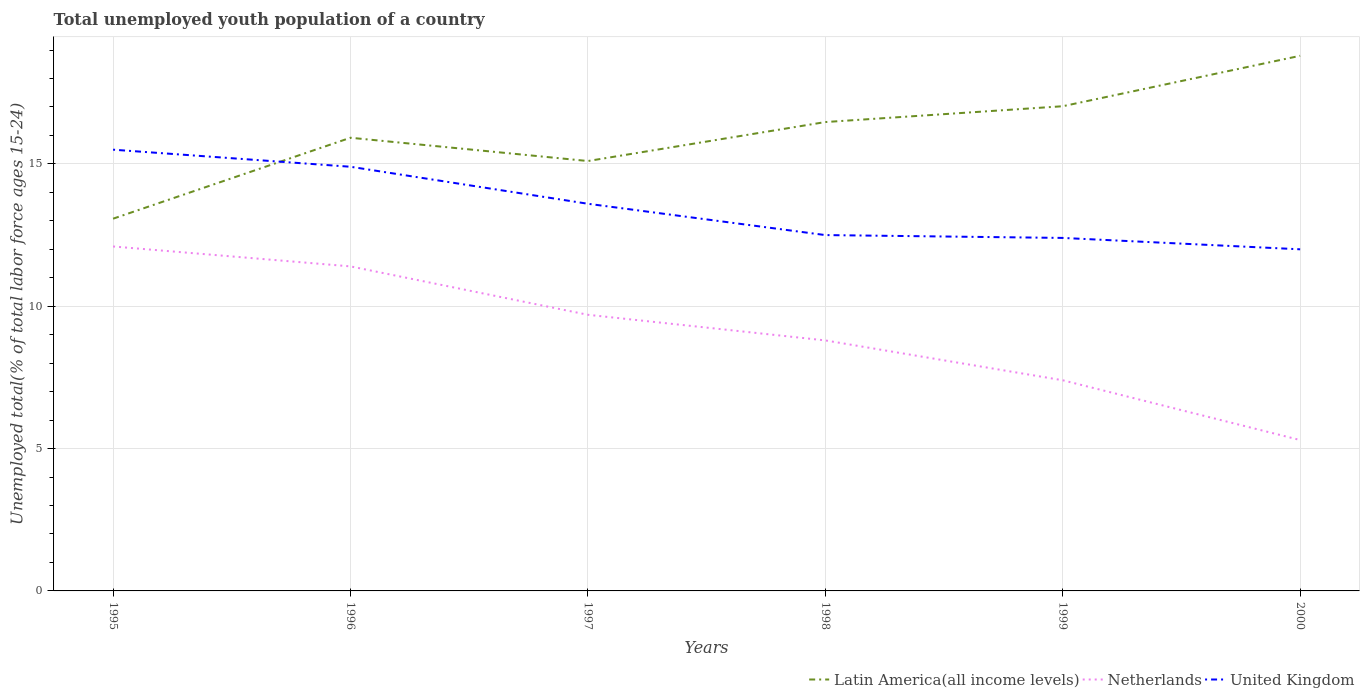How many different coloured lines are there?
Offer a very short reply. 3. Is the number of lines equal to the number of legend labels?
Your response must be concise. Yes. In which year was the percentage of total unemployed youth population of a country in Netherlands maximum?
Your answer should be very brief. 2000. What is the total percentage of total unemployed youth population of a country in Latin America(all income levels) in the graph?
Make the answer very short. -2.03. What is the difference between the highest and the second highest percentage of total unemployed youth population of a country in Latin America(all income levels)?
Provide a succinct answer. 5.72. What is the difference between the highest and the lowest percentage of total unemployed youth population of a country in Netherlands?
Your answer should be compact. 3. Is the percentage of total unemployed youth population of a country in United Kingdom strictly greater than the percentage of total unemployed youth population of a country in Latin America(all income levels) over the years?
Provide a short and direct response. No. How many lines are there?
Give a very brief answer. 3. What is the title of the graph?
Offer a very short reply. Total unemployed youth population of a country. What is the label or title of the X-axis?
Offer a very short reply. Years. What is the label or title of the Y-axis?
Offer a very short reply. Unemployed total(% of total labor force ages 15-24). What is the Unemployed total(% of total labor force ages 15-24) in Latin America(all income levels) in 1995?
Offer a very short reply. 13.08. What is the Unemployed total(% of total labor force ages 15-24) in Netherlands in 1995?
Offer a very short reply. 12.1. What is the Unemployed total(% of total labor force ages 15-24) of Latin America(all income levels) in 1996?
Keep it short and to the point. 15.92. What is the Unemployed total(% of total labor force ages 15-24) of Netherlands in 1996?
Offer a very short reply. 11.4. What is the Unemployed total(% of total labor force ages 15-24) of United Kingdom in 1996?
Ensure brevity in your answer.  14.9. What is the Unemployed total(% of total labor force ages 15-24) of Latin America(all income levels) in 1997?
Your answer should be compact. 15.1. What is the Unemployed total(% of total labor force ages 15-24) of Netherlands in 1997?
Keep it short and to the point. 9.7. What is the Unemployed total(% of total labor force ages 15-24) of United Kingdom in 1997?
Give a very brief answer. 13.6. What is the Unemployed total(% of total labor force ages 15-24) in Latin America(all income levels) in 1998?
Your answer should be compact. 16.47. What is the Unemployed total(% of total labor force ages 15-24) of Netherlands in 1998?
Offer a terse response. 8.8. What is the Unemployed total(% of total labor force ages 15-24) in United Kingdom in 1998?
Your answer should be compact. 12.5. What is the Unemployed total(% of total labor force ages 15-24) of Latin America(all income levels) in 1999?
Provide a succinct answer. 17.03. What is the Unemployed total(% of total labor force ages 15-24) of Netherlands in 1999?
Provide a succinct answer. 7.4. What is the Unemployed total(% of total labor force ages 15-24) of United Kingdom in 1999?
Keep it short and to the point. 12.4. What is the Unemployed total(% of total labor force ages 15-24) in Latin America(all income levels) in 2000?
Your answer should be compact. 18.8. What is the Unemployed total(% of total labor force ages 15-24) in Netherlands in 2000?
Make the answer very short. 5.3. What is the Unemployed total(% of total labor force ages 15-24) of United Kingdom in 2000?
Your response must be concise. 12. Across all years, what is the maximum Unemployed total(% of total labor force ages 15-24) in Latin America(all income levels)?
Make the answer very short. 18.8. Across all years, what is the maximum Unemployed total(% of total labor force ages 15-24) of Netherlands?
Make the answer very short. 12.1. Across all years, what is the maximum Unemployed total(% of total labor force ages 15-24) of United Kingdom?
Provide a succinct answer. 15.5. Across all years, what is the minimum Unemployed total(% of total labor force ages 15-24) of Latin America(all income levels)?
Make the answer very short. 13.08. Across all years, what is the minimum Unemployed total(% of total labor force ages 15-24) in Netherlands?
Provide a short and direct response. 5.3. What is the total Unemployed total(% of total labor force ages 15-24) in Latin America(all income levels) in the graph?
Keep it short and to the point. 96.39. What is the total Unemployed total(% of total labor force ages 15-24) in Netherlands in the graph?
Make the answer very short. 54.7. What is the total Unemployed total(% of total labor force ages 15-24) in United Kingdom in the graph?
Provide a short and direct response. 80.9. What is the difference between the Unemployed total(% of total labor force ages 15-24) in Latin America(all income levels) in 1995 and that in 1996?
Offer a very short reply. -2.84. What is the difference between the Unemployed total(% of total labor force ages 15-24) in Latin America(all income levels) in 1995 and that in 1997?
Offer a very short reply. -2.03. What is the difference between the Unemployed total(% of total labor force ages 15-24) in Netherlands in 1995 and that in 1997?
Provide a short and direct response. 2.4. What is the difference between the Unemployed total(% of total labor force ages 15-24) of Latin America(all income levels) in 1995 and that in 1998?
Provide a short and direct response. -3.39. What is the difference between the Unemployed total(% of total labor force ages 15-24) in Netherlands in 1995 and that in 1998?
Your response must be concise. 3.3. What is the difference between the Unemployed total(% of total labor force ages 15-24) of Latin America(all income levels) in 1995 and that in 1999?
Offer a terse response. -3.95. What is the difference between the Unemployed total(% of total labor force ages 15-24) in Netherlands in 1995 and that in 1999?
Ensure brevity in your answer.  4.7. What is the difference between the Unemployed total(% of total labor force ages 15-24) in United Kingdom in 1995 and that in 1999?
Keep it short and to the point. 3.1. What is the difference between the Unemployed total(% of total labor force ages 15-24) of Latin America(all income levels) in 1995 and that in 2000?
Your answer should be very brief. -5.72. What is the difference between the Unemployed total(% of total labor force ages 15-24) of Netherlands in 1995 and that in 2000?
Provide a short and direct response. 6.8. What is the difference between the Unemployed total(% of total labor force ages 15-24) in United Kingdom in 1995 and that in 2000?
Keep it short and to the point. 3.5. What is the difference between the Unemployed total(% of total labor force ages 15-24) in Latin America(all income levels) in 1996 and that in 1997?
Your answer should be very brief. 0.82. What is the difference between the Unemployed total(% of total labor force ages 15-24) of Latin America(all income levels) in 1996 and that in 1998?
Give a very brief answer. -0.55. What is the difference between the Unemployed total(% of total labor force ages 15-24) of United Kingdom in 1996 and that in 1998?
Your answer should be compact. 2.4. What is the difference between the Unemployed total(% of total labor force ages 15-24) of Latin America(all income levels) in 1996 and that in 1999?
Make the answer very short. -1.11. What is the difference between the Unemployed total(% of total labor force ages 15-24) of Netherlands in 1996 and that in 1999?
Your answer should be very brief. 4. What is the difference between the Unemployed total(% of total labor force ages 15-24) of Latin America(all income levels) in 1996 and that in 2000?
Offer a very short reply. -2.88. What is the difference between the Unemployed total(% of total labor force ages 15-24) of United Kingdom in 1996 and that in 2000?
Provide a succinct answer. 2.9. What is the difference between the Unemployed total(% of total labor force ages 15-24) in Latin America(all income levels) in 1997 and that in 1998?
Keep it short and to the point. -1.37. What is the difference between the Unemployed total(% of total labor force ages 15-24) in Netherlands in 1997 and that in 1998?
Your answer should be very brief. 0.9. What is the difference between the Unemployed total(% of total labor force ages 15-24) in Latin America(all income levels) in 1997 and that in 1999?
Give a very brief answer. -1.92. What is the difference between the Unemployed total(% of total labor force ages 15-24) of Netherlands in 1997 and that in 1999?
Your answer should be very brief. 2.3. What is the difference between the Unemployed total(% of total labor force ages 15-24) in Latin America(all income levels) in 1997 and that in 2000?
Keep it short and to the point. -3.7. What is the difference between the Unemployed total(% of total labor force ages 15-24) of Netherlands in 1997 and that in 2000?
Make the answer very short. 4.4. What is the difference between the Unemployed total(% of total labor force ages 15-24) in United Kingdom in 1997 and that in 2000?
Give a very brief answer. 1.6. What is the difference between the Unemployed total(% of total labor force ages 15-24) of Latin America(all income levels) in 1998 and that in 1999?
Give a very brief answer. -0.56. What is the difference between the Unemployed total(% of total labor force ages 15-24) of Netherlands in 1998 and that in 1999?
Your answer should be compact. 1.4. What is the difference between the Unemployed total(% of total labor force ages 15-24) in United Kingdom in 1998 and that in 1999?
Offer a terse response. 0.1. What is the difference between the Unemployed total(% of total labor force ages 15-24) in Latin America(all income levels) in 1998 and that in 2000?
Your answer should be compact. -2.33. What is the difference between the Unemployed total(% of total labor force ages 15-24) in Latin America(all income levels) in 1999 and that in 2000?
Offer a terse response. -1.77. What is the difference between the Unemployed total(% of total labor force ages 15-24) of Latin America(all income levels) in 1995 and the Unemployed total(% of total labor force ages 15-24) of Netherlands in 1996?
Offer a terse response. 1.68. What is the difference between the Unemployed total(% of total labor force ages 15-24) in Latin America(all income levels) in 1995 and the Unemployed total(% of total labor force ages 15-24) in United Kingdom in 1996?
Ensure brevity in your answer.  -1.82. What is the difference between the Unemployed total(% of total labor force ages 15-24) in Netherlands in 1995 and the Unemployed total(% of total labor force ages 15-24) in United Kingdom in 1996?
Provide a short and direct response. -2.8. What is the difference between the Unemployed total(% of total labor force ages 15-24) in Latin America(all income levels) in 1995 and the Unemployed total(% of total labor force ages 15-24) in Netherlands in 1997?
Make the answer very short. 3.38. What is the difference between the Unemployed total(% of total labor force ages 15-24) of Latin America(all income levels) in 1995 and the Unemployed total(% of total labor force ages 15-24) of United Kingdom in 1997?
Your answer should be compact. -0.52. What is the difference between the Unemployed total(% of total labor force ages 15-24) in Latin America(all income levels) in 1995 and the Unemployed total(% of total labor force ages 15-24) in Netherlands in 1998?
Provide a succinct answer. 4.28. What is the difference between the Unemployed total(% of total labor force ages 15-24) of Latin America(all income levels) in 1995 and the Unemployed total(% of total labor force ages 15-24) of United Kingdom in 1998?
Provide a short and direct response. 0.58. What is the difference between the Unemployed total(% of total labor force ages 15-24) of Netherlands in 1995 and the Unemployed total(% of total labor force ages 15-24) of United Kingdom in 1998?
Offer a terse response. -0.4. What is the difference between the Unemployed total(% of total labor force ages 15-24) in Latin America(all income levels) in 1995 and the Unemployed total(% of total labor force ages 15-24) in Netherlands in 1999?
Offer a terse response. 5.68. What is the difference between the Unemployed total(% of total labor force ages 15-24) of Latin America(all income levels) in 1995 and the Unemployed total(% of total labor force ages 15-24) of United Kingdom in 1999?
Offer a terse response. 0.68. What is the difference between the Unemployed total(% of total labor force ages 15-24) of Netherlands in 1995 and the Unemployed total(% of total labor force ages 15-24) of United Kingdom in 1999?
Your answer should be very brief. -0.3. What is the difference between the Unemployed total(% of total labor force ages 15-24) of Latin America(all income levels) in 1995 and the Unemployed total(% of total labor force ages 15-24) of Netherlands in 2000?
Keep it short and to the point. 7.78. What is the difference between the Unemployed total(% of total labor force ages 15-24) in Latin America(all income levels) in 1995 and the Unemployed total(% of total labor force ages 15-24) in United Kingdom in 2000?
Provide a succinct answer. 1.08. What is the difference between the Unemployed total(% of total labor force ages 15-24) in Latin America(all income levels) in 1996 and the Unemployed total(% of total labor force ages 15-24) in Netherlands in 1997?
Make the answer very short. 6.22. What is the difference between the Unemployed total(% of total labor force ages 15-24) in Latin America(all income levels) in 1996 and the Unemployed total(% of total labor force ages 15-24) in United Kingdom in 1997?
Ensure brevity in your answer.  2.32. What is the difference between the Unemployed total(% of total labor force ages 15-24) in Latin America(all income levels) in 1996 and the Unemployed total(% of total labor force ages 15-24) in Netherlands in 1998?
Give a very brief answer. 7.12. What is the difference between the Unemployed total(% of total labor force ages 15-24) of Latin America(all income levels) in 1996 and the Unemployed total(% of total labor force ages 15-24) of United Kingdom in 1998?
Offer a terse response. 3.42. What is the difference between the Unemployed total(% of total labor force ages 15-24) of Netherlands in 1996 and the Unemployed total(% of total labor force ages 15-24) of United Kingdom in 1998?
Keep it short and to the point. -1.1. What is the difference between the Unemployed total(% of total labor force ages 15-24) of Latin America(all income levels) in 1996 and the Unemployed total(% of total labor force ages 15-24) of Netherlands in 1999?
Your response must be concise. 8.52. What is the difference between the Unemployed total(% of total labor force ages 15-24) of Latin America(all income levels) in 1996 and the Unemployed total(% of total labor force ages 15-24) of United Kingdom in 1999?
Your answer should be compact. 3.52. What is the difference between the Unemployed total(% of total labor force ages 15-24) in Netherlands in 1996 and the Unemployed total(% of total labor force ages 15-24) in United Kingdom in 1999?
Provide a succinct answer. -1. What is the difference between the Unemployed total(% of total labor force ages 15-24) of Latin America(all income levels) in 1996 and the Unemployed total(% of total labor force ages 15-24) of Netherlands in 2000?
Provide a short and direct response. 10.62. What is the difference between the Unemployed total(% of total labor force ages 15-24) of Latin America(all income levels) in 1996 and the Unemployed total(% of total labor force ages 15-24) of United Kingdom in 2000?
Provide a short and direct response. 3.92. What is the difference between the Unemployed total(% of total labor force ages 15-24) of Latin America(all income levels) in 1997 and the Unemployed total(% of total labor force ages 15-24) of Netherlands in 1998?
Make the answer very short. 6.3. What is the difference between the Unemployed total(% of total labor force ages 15-24) of Latin America(all income levels) in 1997 and the Unemployed total(% of total labor force ages 15-24) of United Kingdom in 1998?
Provide a short and direct response. 2.6. What is the difference between the Unemployed total(% of total labor force ages 15-24) in Netherlands in 1997 and the Unemployed total(% of total labor force ages 15-24) in United Kingdom in 1998?
Provide a succinct answer. -2.8. What is the difference between the Unemployed total(% of total labor force ages 15-24) in Latin America(all income levels) in 1997 and the Unemployed total(% of total labor force ages 15-24) in Netherlands in 1999?
Give a very brief answer. 7.7. What is the difference between the Unemployed total(% of total labor force ages 15-24) in Latin America(all income levels) in 1997 and the Unemployed total(% of total labor force ages 15-24) in United Kingdom in 1999?
Give a very brief answer. 2.7. What is the difference between the Unemployed total(% of total labor force ages 15-24) of Latin America(all income levels) in 1997 and the Unemployed total(% of total labor force ages 15-24) of Netherlands in 2000?
Your answer should be very brief. 9.8. What is the difference between the Unemployed total(% of total labor force ages 15-24) of Latin America(all income levels) in 1997 and the Unemployed total(% of total labor force ages 15-24) of United Kingdom in 2000?
Provide a succinct answer. 3.1. What is the difference between the Unemployed total(% of total labor force ages 15-24) in Latin America(all income levels) in 1998 and the Unemployed total(% of total labor force ages 15-24) in Netherlands in 1999?
Offer a very short reply. 9.07. What is the difference between the Unemployed total(% of total labor force ages 15-24) of Latin America(all income levels) in 1998 and the Unemployed total(% of total labor force ages 15-24) of United Kingdom in 1999?
Your answer should be compact. 4.07. What is the difference between the Unemployed total(% of total labor force ages 15-24) in Netherlands in 1998 and the Unemployed total(% of total labor force ages 15-24) in United Kingdom in 1999?
Provide a succinct answer. -3.6. What is the difference between the Unemployed total(% of total labor force ages 15-24) of Latin America(all income levels) in 1998 and the Unemployed total(% of total labor force ages 15-24) of Netherlands in 2000?
Make the answer very short. 11.17. What is the difference between the Unemployed total(% of total labor force ages 15-24) of Latin America(all income levels) in 1998 and the Unemployed total(% of total labor force ages 15-24) of United Kingdom in 2000?
Your answer should be very brief. 4.47. What is the difference between the Unemployed total(% of total labor force ages 15-24) in Latin America(all income levels) in 1999 and the Unemployed total(% of total labor force ages 15-24) in Netherlands in 2000?
Provide a short and direct response. 11.73. What is the difference between the Unemployed total(% of total labor force ages 15-24) of Latin America(all income levels) in 1999 and the Unemployed total(% of total labor force ages 15-24) of United Kingdom in 2000?
Ensure brevity in your answer.  5.03. What is the difference between the Unemployed total(% of total labor force ages 15-24) in Netherlands in 1999 and the Unemployed total(% of total labor force ages 15-24) in United Kingdom in 2000?
Ensure brevity in your answer.  -4.6. What is the average Unemployed total(% of total labor force ages 15-24) of Latin America(all income levels) per year?
Your answer should be compact. 16.07. What is the average Unemployed total(% of total labor force ages 15-24) of Netherlands per year?
Offer a very short reply. 9.12. What is the average Unemployed total(% of total labor force ages 15-24) of United Kingdom per year?
Offer a terse response. 13.48. In the year 1995, what is the difference between the Unemployed total(% of total labor force ages 15-24) of Latin America(all income levels) and Unemployed total(% of total labor force ages 15-24) of Netherlands?
Keep it short and to the point. 0.98. In the year 1995, what is the difference between the Unemployed total(% of total labor force ages 15-24) of Latin America(all income levels) and Unemployed total(% of total labor force ages 15-24) of United Kingdom?
Offer a very short reply. -2.42. In the year 1995, what is the difference between the Unemployed total(% of total labor force ages 15-24) in Netherlands and Unemployed total(% of total labor force ages 15-24) in United Kingdom?
Your answer should be compact. -3.4. In the year 1996, what is the difference between the Unemployed total(% of total labor force ages 15-24) in Latin America(all income levels) and Unemployed total(% of total labor force ages 15-24) in Netherlands?
Your response must be concise. 4.52. In the year 1996, what is the difference between the Unemployed total(% of total labor force ages 15-24) of Latin America(all income levels) and Unemployed total(% of total labor force ages 15-24) of United Kingdom?
Your answer should be compact. 1.02. In the year 1997, what is the difference between the Unemployed total(% of total labor force ages 15-24) of Latin America(all income levels) and Unemployed total(% of total labor force ages 15-24) of Netherlands?
Provide a succinct answer. 5.4. In the year 1997, what is the difference between the Unemployed total(% of total labor force ages 15-24) in Latin America(all income levels) and Unemployed total(% of total labor force ages 15-24) in United Kingdom?
Provide a succinct answer. 1.5. In the year 1997, what is the difference between the Unemployed total(% of total labor force ages 15-24) in Netherlands and Unemployed total(% of total labor force ages 15-24) in United Kingdom?
Your answer should be very brief. -3.9. In the year 1998, what is the difference between the Unemployed total(% of total labor force ages 15-24) in Latin America(all income levels) and Unemployed total(% of total labor force ages 15-24) in Netherlands?
Offer a terse response. 7.67. In the year 1998, what is the difference between the Unemployed total(% of total labor force ages 15-24) in Latin America(all income levels) and Unemployed total(% of total labor force ages 15-24) in United Kingdom?
Ensure brevity in your answer.  3.97. In the year 1998, what is the difference between the Unemployed total(% of total labor force ages 15-24) in Netherlands and Unemployed total(% of total labor force ages 15-24) in United Kingdom?
Make the answer very short. -3.7. In the year 1999, what is the difference between the Unemployed total(% of total labor force ages 15-24) in Latin America(all income levels) and Unemployed total(% of total labor force ages 15-24) in Netherlands?
Make the answer very short. 9.63. In the year 1999, what is the difference between the Unemployed total(% of total labor force ages 15-24) in Latin America(all income levels) and Unemployed total(% of total labor force ages 15-24) in United Kingdom?
Offer a very short reply. 4.63. In the year 2000, what is the difference between the Unemployed total(% of total labor force ages 15-24) of Latin America(all income levels) and Unemployed total(% of total labor force ages 15-24) of Netherlands?
Keep it short and to the point. 13.5. In the year 2000, what is the difference between the Unemployed total(% of total labor force ages 15-24) in Latin America(all income levels) and Unemployed total(% of total labor force ages 15-24) in United Kingdom?
Make the answer very short. 6.8. What is the ratio of the Unemployed total(% of total labor force ages 15-24) of Latin America(all income levels) in 1995 to that in 1996?
Offer a very short reply. 0.82. What is the ratio of the Unemployed total(% of total labor force ages 15-24) in Netherlands in 1995 to that in 1996?
Offer a terse response. 1.06. What is the ratio of the Unemployed total(% of total labor force ages 15-24) of United Kingdom in 1995 to that in 1996?
Make the answer very short. 1.04. What is the ratio of the Unemployed total(% of total labor force ages 15-24) in Latin America(all income levels) in 1995 to that in 1997?
Offer a very short reply. 0.87. What is the ratio of the Unemployed total(% of total labor force ages 15-24) in Netherlands in 1995 to that in 1997?
Your response must be concise. 1.25. What is the ratio of the Unemployed total(% of total labor force ages 15-24) of United Kingdom in 1995 to that in 1997?
Your answer should be compact. 1.14. What is the ratio of the Unemployed total(% of total labor force ages 15-24) of Latin America(all income levels) in 1995 to that in 1998?
Make the answer very short. 0.79. What is the ratio of the Unemployed total(% of total labor force ages 15-24) of Netherlands in 1995 to that in 1998?
Your answer should be compact. 1.38. What is the ratio of the Unemployed total(% of total labor force ages 15-24) of United Kingdom in 1995 to that in 1998?
Your answer should be very brief. 1.24. What is the ratio of the Unemployed total(% of total labor force ages 15-24) of Latin America(all income levels) in 1995 to that in 1999?
Your response must be concise. 0.77. What is the ratio of the Unemployed total(% of total labor force ages 15-24) of Netherlands in 1995 to that in 1999?
Give a very brief answer. 1.64. What is the ratio of the Unemployed total(% of total labor force ages 15-24) of United Kingdom in 1995 to that in 1999?
Offer a very short reply. 1.25. What is the ratio of the Unemployed total(% of total labor force ages 15-24) in Latin America(all income levels) in 1995 to that in 2000?
Your answer should be very brief. 0.7. What is the ratio of the Unemployed total(% of total labor force ages 15-24) in Netherlands in 1995 to that in 2000?
Provide a short and direct response. 2.28. What is the ratio of the Unemployed total(% of total labor force ages 15-24) in United Kingdom in 1995 to that in 2000?
Your answer should be compact. 1.29. What is the ratio of the Unemployed total(% of total labor force ages 15-24) of Latin America(all income levels) in 1996 to that in 1997?
Offer a terse response. 1.05. What is the ratio of the Unemployed total(% of total labor force ages 15-24) of Netherlands in 1996 to that in 1997?
Your answer should be very brief. 1.18. What is the ratio of the Unemployed total(% of total labor force ages 15-24) in United Kingdom in 1996 to that in 1997?
Make the answer very short. 1.1. What is the ratio of the Unemployed total(% of total labor force ages 15-24) of Latin America(all income levels) in 1996 to that in 1998?
Your response must be concise. 0.97. What is the ratio of the Unemployed total(% of total labor force ages 15-24) in Netherlands in 1996 to that in 1998?
Your response must be concise. 1.3. What is the ratio of the Unemployed total(% of total labor force ages 15-24) of United Kingdom in 1996 to that in 1998?
Make the answer very short. 1.19. What is the ratio of the Unemployed total(% of total labor force ages 15-24) in Latin America(all income levels) in 1996 to that in 1999?
Offer a terse response. 0.94. What is the ratio of the Unemployed total(% of total labor force ages 15-24) of Netherlands in 1996 to that in 1999?
Offer a terse response. 1.54. What is the ratio of the Unemployed total(% of total labor force ages 15-24) of United Kingdom in 1996 to that in 1999?
Your answer should be very brief. 1.2. What is the ratio of the Unemployed total(% of total labor force ages 15-24) in Latin America(all income levels) in 1996 to that in 2000?
Provide a succinct answer. 0.85. What is the ratio of the Unemployed total(% of total labor force ages 15-24) of Netherlands in 1996 to that in 2000?
Keep it short and to the point. 2.15. What is the ratio of the Unemployed total(% of total labor force ages 15-24) in United Kingdom in 1996 to that in 2000?
Provide a short and direct response. 1.24. What is the ratio of the Unemployed total(% of total labor force ages 15-24) of Latin America(all income levels) in 1997 to that in 1998?
Your answer should be compact. 0.92. What is the ratio of the Unemployed total(% of total labor force ages 15-24) of Netherlands in 1997 to that in 1998?
Make the answer very short. 1.1. What is the ratio of the Unemployed total(% of total labor force ages 15-24) of United Kingdom in 1997 to that in 1998?
Ensure brevity in your answer.  1.09. What is the ratio of the Unemployed total(% of total labor force ages 15-24) in Latin America(all income levels) in 1997 to that in 1999?
Offer a very short reply. 0.89. What is the ratio of the Unemployed total(% of total labor force ages 15-24) in Netherlands in 1997 to that in 1999?
Offer a very short reply. 1.31. What is the ratio of the Unemployed total(% of total labor force ages 15-24) of United Kingdom in 1997 to that in 1999?
Your answer should be very brief. 1.1. What is the ratio of the Unemployed total(% of total labor force ages 15-24) of Latin America(all income levels) in 1997 to that in 2000?
Provide a succinct answer. 0.8. What is the ratio of the Unemployed total(% of total labor force ages 15-24) of Netherlands in 1997 to that in 2000?
Keep it short and to the point. 1.83. What is the ratio of the Unemployed total(% of total labor force ages 15-24) in United Kingdom in 1997 to that in 2000?
Offer a terse response. 1.13. What is the ratio of the Unemployed total(% of total labor force ages 15-24) in Latin America(all income levels) in 1998 to that in 1999?
Your response must be concise. 0.97. What is the ratio of the Unemployed total(% of total labor force ages 15-24) in Netherlands in 1998 to that in 1999?
Offer a very short reply. 1.19. What is the ratio of the Unemployed total(% of total labor force ages 15-24) of United Kingdom in 1998 to that in 1999?
Your response must be concise. 1.01. What is the ratio of the Unemployed total(% of total labor force ages 15-24) in Latin America(all income levels) in 1998 to that in 2000?
Offer a very short reply. 0.88. What is the ratio of the Unemployed total(% of total labor force ages 15-24) of Netherlands in 1998 to that in 2000?
Offer a terse response. 1.66. What is the ratio of the Unemployed total(% of total labor force ages 15-24) of United Kingdom in 1998 to that in 2000?
Ensure brevity in your answer.  1.04. What is the ratio of the Unemployed total(% of total labor force ages 15-24) in Latin America(all income levels) in 1999 to that in 2000?
Offer a very short reply. 0.91. What is the ratio of the Unemployed total(% of total labor force ages 15-24) in Netherlands in 1999 to that in 2000?
Your answer should be compact. 1.4. What is the ratio of the Unemployed total(% of total labor force ages 15-24) of United Kingdom in 1999 to that in 2000?
Offer a terse response. 1.03. What is the difference between the highest and the second highest Unemployed total(% of total labor force ages 15-24) of Latin America(all income levels)?
Offer a terse response. 1.77. What is the difference between the highest and the second highest Unemployed total(% of total labor force ages 15-24) in Netherlands?
Offer a very short reply. 0.7. What is the difference between the highest and the second highest Unemployed total(% of total labor force ages 15-24) of United Kingdom?
Offer a very short reply. 0.6. What is the difference between the highest and the lowest Unemployed total(% of total labor force ages 15-24) in Latin America(all income levels)?
Provide a short and direct response. 5.72. What is the difference between the highest and the lowest Unemployed total(% of total labor force ages 15-24) of United Kingdom?
Your response must be concise. 3.5. 